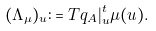<formula> <loc_0><loc_0><loc_500><loc_500>( \Lambda _ { \mu } ) _ { u } \colon = T q _ { A } | _ { u } ^ { t } \mu ( u ) .</formula> 